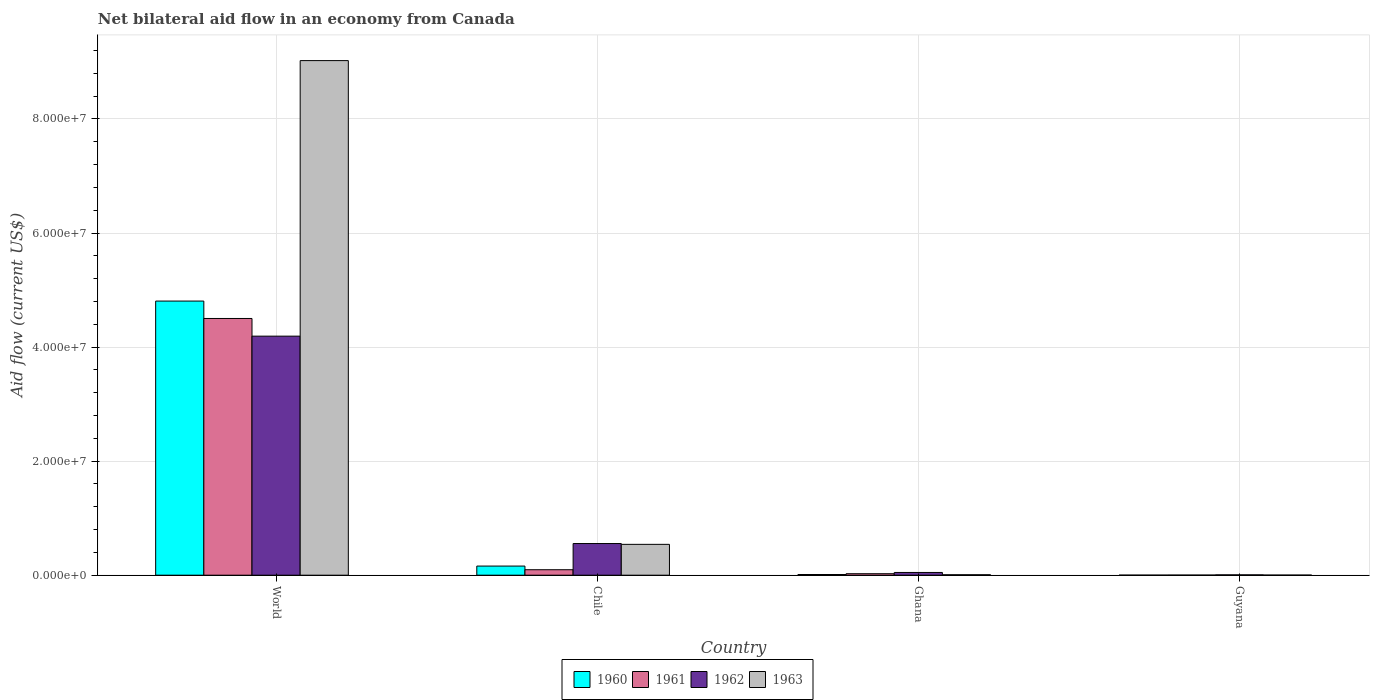Are the number of bars per tick equal to the number of legend labels?
Make the answer very short. Yes. Are the number of bars on each tick of the X-axis equal?
Offer a terse response. Yes. How many bars are there on the 2nd tick from the left?
Provide a short and direct response. 4. How many bars are there on the 4th tick from the right?
Offer a very short reply. 4. What is the label of the 2nd group of bars from the left?
Your answer should be compact. Chile. What is the net bilateral aid flow in 1960 in Chile?
Your response must be concise. 1.60e+06. Across all countries, what is the maximum net bilateral aid flow in 1961?
Keep it short and to the point. 4.50e+07. Across all countries, what is the minimum net bilateral aid flow in 1960?
Give a very brief answer. 10000. In which country was the net bilateral aid flow in 1961 maximum?
Ensure brevity in your answer.  World. In which country was the net bilateral aid flow in 1960 minimum?
Make the answer very short. Guyana. What is the total net bilateral aid flow in 1960 in the graph?
Provide a short and direct response. 4.98e+07. What is the difference between the net bilateral aid flow in 1962 in Guyana and the net bilateral aid flow in 1960 in World?
Provide a short and direct response. -4.80e+07. What is the average net bilateral aid flow in 1962 per country?
Give a very brief answer. 1.20e+07. What is the difference between the net bilateral aid flow of/in 1962 and net bilateral aid flow of/in 1961 in Ghana?
Your response must be concise. 2.20e+05. In how many countries, is the net bilateral aid flow in 1963 greater than 8000000 US$?
Ensure brevity in your answer.  1. What is the ratio of the net bilateral aid flow in 1963 in Chile to that in World?
Provide a succinct answer. 0.06. Is the net bilateral aid flow in 1961 in Chile less than that in Ghana?
Your answer should be very brief. No. What is the difference between the highest and the second highest net bilateral aid flow in 1963?
Ensure brevity in your answer.  9.02e+07. What is the difference between the highest and the lowest net bilateral aid flow in 1962?
Ensure brevity in your answer.  4.19e+07. In how many countries, is the net bilateral aid flow in 1962 greater than the average net bilateral aid flow in 1962 taken over all countries?
Make the answer very short. 1. Is the sum of the net bilateral aid flow in 1960 in Chile and Ghana greater than the maximum net bilateral aid flow in 1962 across all countries?
Give a very brief answer. No. Is it the case that in every country, the sum of the net bilateral aid flow in 1962 and net bilateral aid flow in 1963 is greater than the sum of net bilateral aid flow in 1960 and net bilateral aid flow in 1961?
Keep it short and to the point. No. What is the difference between two consecutive major ticks on the Y-axis?
Provide a succinct answer. 2.00e+07. Does the graph contain any zero values?
Your answer should be very brief. No. How are the legend labels stacked?
Make the answer very short. Horizontal. What is the title of the graph?
Your answer should be very brief. Net bilateral aid flow in an economy from Canada. What is the label or title of the Y-axis?
Keep it short and to the point. Aid flow (current US$). What is the Aid flow (current US$) of 1960 in World?
Offer a very short reply. 4.81e+07. What is the Aid flow (current US$) of 1961 in World?
Provide a short and direct response. 4.50e+07. What is the Aid flow (current US$) in 1962 in World?
Offer a terse response. 4.19e+07. What is the Aid flow (current US$) in 1963 in World?
Make the answer very short. 9.02e+07. What is the Aid flow (current US$) in 1960 in Chile?
Keep it short and to the point. 1.60e+06. What is the Aid flow (current US$) of 1961 in Chile?
Your answer should be very brief. 9.60e+05. What is the Aid flow (current US$) of 1962 in Chile?
Your answer should be very brief. 5.55e+06. What is the Aid flow (current US$) of 1963 in Chile?
Offer a very short reply. 5.41e+06. What is the Aid flow (current US$) of 1960 in Ghana?
Ensure brevity in your answer.  1.20e+05. What is the Aid flow (current US$) in 1961 in Ghana?
Keep it short and to the point. 2.60e+05. What is the Aid flow (current US$) in 1960 in Guyana?
Provide a succinct answer. 10000. What is the Aid flow (current US$) in 1961 in Guyana?
Provide a succinct answer. 2.00e+04. What is the Aid flow (current US$) in 1962 in Guyana?
Offer a terse response. 6.00e+04. What is the Aid flow (current US$) of 1963 in Guyana?
Your response must be concise. 2.00e+04. Across all countries, what is the maximum Aid flow (current US$) of 1960?
Your response must be concise. 4.81e+07. Across all countries, what is the maximum Aid flow (current US$) of 1961?
Provide a short and direct response. 4.50e+07. Across all countries, what is the maximum Aid flow (current US$) in 1962?
Make the answer very short. 4.19e+07. Across all countries, what is the maximum Aid flow (current US$) of 1963?
Provide a succinct answer. 9.02e+07. Across all countries, what is the minimum Aid flow (current US$) in 1960?
Make the answer very short. 10000. Across all countries, what is the minimum Aid flow (current US$) of 1961?
Offer a very short reply. 2.00e+04. Across all countries, what is the minimum Aid flow (current US$) in 1962?
Give a very brief answer. 6.00e+04. What is the total Aid flow (current US$) of 1960 in the graph?
Your answer should be very brief. 4.98e+07. What is the total Aid flow (current US$) in 1961 in the graph?
Your response must be concise. 4.63e+07. What is the total Aid flow (current US$) of 1962 in the graph?
Your response must be concise. 4.80e+07. What is the total Aid flow (current US$) of 1963 in the graph?
Give a very brief answer. 9.58e+07. What is the difference between the Aid flow (current US$) in 1960 in World and that in Chile?
Your answer should be compact. 4.65e+07. What is the difference between the Aid flow (current US$) in 1961 in World and that in Chile?
Your answer should be very brief. 4.41e+07. What is the difference between the Aid flow (current US$) in 1962 in World and that in Chile?
Make the answer very short. 3.64e+07. What is the difference between the Aid flow (current US$) in 1963 in World and that in Chile?
Offer a very short reply. 8.48e+07. What is the difference between the Aid flow (current US$) in 1960 in World and that in Ghana?
Make the answer very short. 4.80e+07. What is the difference between the Aid flow (current US$) of 1961 in World and that in Ghana?
Your answer should be compact. 4.48e+07. What is the difference between the Aid flow (current US$) of 1962 in World and that in Ghana?
Provide a succinct answer. 4.14e+07. What is the difference between the Aid flow (current US$) of 1963 in World and that in Ghana?
Ensure brevity in your answer.  9.02e+07. What is the difference between the Aid flow (current US$) in 1960 in World and that in Guyana?
Make the answer very short. 4.81e+07. What is the difference between the Aid flow (current US$) of 1961 in World and that in Guyana?
Make the answer very short. 4.50e+07. What is the difference between the Aid flow (current US$) in 1962 in World and that in Guyana?
Your answer should be very brief. 4.19e+07. What is the difference between the Aid flow (current US$) in 1963 in World and that in Guyana?
Offer a terse response. 9.02e+07. What is the difference between the Aid flow (current US$) of 1960 in Chile and that in Ghana?
Provide a short and direct response. 1.48e+06. What is the difference between the Aid flow (current US$) of 1962 in Chile and that in Ghana?
Offer a terse response. 5.07e+06. What is the difference between the Aid flow (current US$) of 1963 in Chile and that in Ghana?
Your answer should be very brief. 5.33e+06. What is the difference between the Aid flow (current US$) of 1960 in Chile and that in Guyana?
Offer a very short reply. 1.59e+06. What is the difference between the Aid flow (current US$) in 1961 in Chile and that in Guyana?
Provide a short and direct response. 9.40e+05. What is the difference between the Aid flow (current US$) of 1962 in Chile and that in Guyana?
Your answer should be very brief. 5.49e+06. What is the difference between the Aid flow (current US$) of 1963 in Chile and that in Guyana?
Give a very brief answer. 5.39e+06. What is the difference between the Aid flow (current US$) in 1961 in Ghana and that in Guyana?
Provide a short and direct response. 2.40e+05. What is the difference between the Aid flow (current US$) in 1960 in World and the Aid flow (current US$) in 1961 in Chile?
Provide a succinct answer. 4.71e+07. What is the difference between the Aid flow (current US$) of 1960 in World and the Aid flow (current US$) of 1962 in Chile?
Offer a terse response. 4.25e+07. What is the difference between the Aid flow (current US$) of 1960 in World and the Aid flow (current US$) of 1963 in Chile?
Make the answer very short. 4.27e+07. What is the difference between the Aid flow (current US$) of 1961 in World and the Aid flow (current US$) of 1962 in Chile?
Ensure brevity in your answer.  3.95e+07. What is the difference between the Aid flow (current US$) of 1961 in World and the Aid flow (current US$) of 1963 in Chile?
Your answer should be very brief. 3.96e+07. What is the difference between the Aid flow (current US$) of 1962 in World and the Aid flow (current US$) of 1963 in Chile?
Offer a terse response. 3.65e+07. What is the difference between the Aid flow (current US$) in 1960 in World and the Aid flow (current US$) in 1961 in Ghana?
Give a very brief answer. 4.78e+07. What is the difference between the Aid flow (current US$) in 1960 in World and the Aid flow (current US$) in 1962 in Ghana?
Keep it short and to the point. 4.76e+07. What is the difference between the Aid flow (current US$) of 1960 in World and the Aid flow (current US$) of 1963 in Ghana?
Give a very brief answer. 4.80e+07. What is the difference between the Aid flow (current US$) in 1961 in World and the Aid flow (current US$) in 1962 in Ghana?
Make the answer very short. 4.45e+07. What is the difference between the Aid flow (current US$) in 1961 in World and the Aid flow (current US$) in 1963 in Ghana?
Provide a short and direct response. 4.49e+07. What is the difference between the Aid flow (current US$) in 1962 in World and the Aid flow (current US$) in 1963 in Ghana?
Give a very brief answer. 4.18e+07. What is the difference between the Aid flow (current US$) in 1960 in World and the Aid flow (current US$) in 1961 in Guyana?
Offer a terse response. 4.80e+07. What is the difference between the Aid flow (current US$) of 1960 in World and the Aid flow (current US$) of 1962 in Guyana?
Provide a succinct answer. 4.80e+07. What is the difference between the Aid flow (current US$) in 1960 in World and the Aid flow (current US$) in 1963 in Guyana?
Your answer should be very brief. 4.80e+07. What is the difference between the Aid flow (current US$) of 1961 in World and the Aid flow (current US$) of 1962 in Guyana?
Offer a very short reply. 4.50e+07. What is the difference between the Aid flow (current US$) of 1961 in World and the Aid flow (current US$) of 1963 in Guyana?
Give a very brief answer. 4.50e+07. What is the difference between the Aid flow (current US$) in 1962 in World and the Aid flow (current US$) in 1963 in Guyana?
Provide a short and direct response. 4.19e+07. What is the difference between the Aid flow (current US$) of 1960 in Chile and the Aid flow (current US$) of 1961 in Ghana?
Give a very brief answer. 1.34e+06. What is the difference between the Aid flow (current US$) of 1960 in Chile and the Aid flow (current US$) of 1962 in Ghana?
Keep it short and to the point. 1.12e+06. What is the difference between the Aid flow (current US$) of 1960 in Chile and the Aid flow (current US$) of 1963 in Ghana?
Your answer should be compact. 1.52e+06. What is the difference between the Aid flow (current US$) of 1961 in Chile and the Aid flow (current US$) of 1962 in Ghana?
Make the answer very short. 4.80e+05. What is the difference between the Aid flow (current US$) in 1961 in Chile and the Aid flow (current US$) in 1963 in Ghana?
Offer a terse response. 8.80e+05. What is the difference between the Aid flow (current US$) of 1962 in Chile and the Aid flow (current US$) of 1963 in Ghana?
Provide a succinct answer. 5.47e+06. What is the difference between the Aid flow (current US$) of 1960 in Chile and the Aid flow (current US$) of 1961 in Guyana?
Your answer should be compact. 1.58e+06. What is the difference between the Aid flow (current US$) in 1960 in Chile and the Aid flow (current US$) in 1962 in Guyana?
Your response must be concise. 1.54e+06. What is the difference between the Aid flow (current US$) in 1960 in Chile and the Aid flow (current US$) in 1963 in Guyana?
Make the answer very short. 1.58e+06. What is the difference between the Aid flow (current US$) in 1961 in Chile and the Aid flow (current US$) in 1963 in Guyana?
Provide a short and direct response. 9.40e+05. What is the difference between the Aid flow (current US$) of 1962 in Chile and the Aid flow (current US$) of 1963 in Guyana?
Give a very brief answer. 5.53e+06. What is the difference between the Aid flow (current US$) in 1961 in Ghana and the Aid flow (current US$) in 1962 in Guyana?
Give a very brief answer. 2.00e+05. What is the difference between the Aid flow (current US$) in 1961 in Ghana and the Aid flow (current US$) in 1963 in Guyana?
Make the answer very short. 2.40e+05. What is the difference between the Aid flow (current US$) in 1962 in Ghana and the Aid flow (current US$) in 1963 in Guyana?
Provide a short and direct response. 4.60e+05. What is the average Aid flow (current US$) of 1960 per country?
Your answer should be very brief. 1.24e+07. What is the average Aid flow (current US$) of 1961 per country?
Your response must be concise. 1.16e+07. What is the average Aid flow (current US$) of 1962 per country?
Your answer should be very brief. 1.20e+07. What is the average Aid flow (current US$) in 1963 per country?
Your response must be concise. 2.39e+07. What is the difference between the Aid flow (current US$) of 1960 and Aid flow (current US$) of 1961 in World?
Provide a succinct answer. 3.05e+06. What is the difference between the Aid flow (current US$) of 1960 and Aid flow (current US$) of 1962 in World?
Your response must be concise. 6.15e+06. What is the difference between the Aid flow (current US$) in 1960 and Aid flow (current US$) in 1963 in World?
Keep it short and to the point. -4.22e+07. What is the difference between the Aid flow (current US$) of 1961 and Aid flow (current US$) of 1962 in World?
Your response must be concise. 3.10e+06. What is the difference between the Aid flow (current US$) of 1961 and Aid flow (current US$) of 1963 in World?
Ensure brevity in your answer.  -4.52e+07. What is the difference between the Aid flow (current US$) in 1962 and Aid flow (current US$) in 1963 in World?
Your response must be concise. -4.83e+07. What is the difference between the Aid flow (current US$) in 1960 and Aid flow (current US$) in 1961 in Chile?
Ensure brevity in your answer.  6.40e+05. What is the difference between the Aid flow (current US$) of 1960 and Aid flow (current US$) of 1962 in Chile?
Your answer should be very brief. -3.95e+06. What is the difference between the Aid flow (current US$) of 1960 and Aid flow (current US$) of 1963 in Chile?
Keep it short and to the point. -3.81e+06. What is the difference between the Aid flow (current US$) in 1961 and Aid flow (current US$) in 1962 in Chile?
Make the answer very short. -4.59e+06. What is the difference between the Aid flow (current US$) in 1961 and Aid flow (current US$) in 1963 in Chile?
Provide a succinct answer. -4.45e+06. What is the difference between the Aid flow (current US$) of 1962 and Aid flow (current US$) of 1963 in Chile?
Offer a very short reply. 1.40e+05. What is the difference between the Aid flow (current US$) in 1960 and Aid flow (current US$) in 1962 in Ghana?
Ensure brevity in your answer.  -3.60e+05. What is the difference between the Aid flow (current US$) of 1961 and Aid flow (current US$) of 1963 in Ghana?
Provide a succinct answer. 1.80e+05. What is the difference between the Aid flow (current US$) in 1960 and Aid flow (current US$) in 1963 in Guyana?
Provide a succinct answer. -10000. What is the difference between the Aid flow (current US$) of 1961 and Aid flow (current US$) of 1962 in Guyana?
Provide a succinct answer. -4.00e+04. What is the difference between the Aid flow (current US$) of 1961 and Aid flow (current US$) of 1963 in Guyana?
Keep it short and to the point. 0. What is the ratio of the Aid flow (current US$) of 1960 in World to that in Chile?
Give a very brief answer. 30.04. What is the ratio of the Aid flow (current US$) in 1961 in World to that in Chile?
Your answer should be compact. 46.9. What is the ratio of the Aid flow (current US$) in 1962 in World to that in Chile?
Ensure brevity in your answer.  7.55. What is the ratio of the Aid flow (current US$) of 1963 in World to that in Chile?
Make the answer very short. 16.68. What is the ratio of the Aid flow (current US$) of 1960 in World to that in Ghana?
Provide a succinct answer. 400.58. What is the ratio of the Aid flow (current US$) in 1961 in World to that in Ghana?
Make the answer very short. 173.15. What is the ratio of the Aid flow (current US$) of 1962 in World to that in Ghana?
Your answer should be very brief. 87.33. What is the ratio of the Aid flow (current US$) in 1963 in World to that in Ghana?
Your answer should be compact. 1128. What is the ratio of the Aid flow (current US$) in 1960 in World to that in Guyana?
Your response must be concise. 4807. What is the ratio of the Aid flow (current US$) of 1961 in World to that in Guyana?
Your answer should be very brief. 2251. What is the ratio of the Aid flow (current US$) of 1962 in World to that in Guyana?
Your answer should be compact. 698.67. What is the ratio of the Aid flow (current US$) in 1963 in World to that in Guyana?
Provide a short and direct response. 4512. What is the ratio of the Aid flow (current US$) in 1960 in Chile to that in Ghana?
Make the answer very short. 13.33. What is the ratio of the Aid flow (current US$) in 1961 in Chile to that in Ghana?
Ensure brevity in your answer.  3.69. What is the ratio of the Aid flow (current US$) in 1962 in Chile to that in Ghana?
Ensure brevity in your answer.  11.56. What is the ratio of the Aid flow (current US$) in 1963 in Chile to that in Ghana?
Give a very brief answer. 67.62. What is the ratio of the Aid flow (current US$) in 1960 in Chile to that in Guyana?
Ensure brevity in your answer.  160. What is the ratio of the Aid flow (current US$) in 1961 in Chile to that in Guyana?
Your answer should be compact. 48. What is the ratio of the Aid flow (current US$) of 1962 in Chile to that in Guyana?
Offer a very short reply. 92.5. What is the ratio of the Aid flow (current US$) of 1963 in Chile to that in Guyana?
Give a very brief answer. 270.5. What is the ratio of the Aid flow (current US$) of 1960 in Ghana to that in Guyana?
Offer a terse response. 12. What is the ratio of the Aid flow (current US$) in 1963 in Ghana to that in Guyana?
Keep it short and to the point. 4. What is the difference between the highest and the second highest Aid flow (current US$) in 1960?
Your answer should be compact. 4.65e+07. What is the difference between the highest and the second highest Aid flow (current US$) in 1961?
Provide a short and direct response. 4.41e+07. What is the difference between the highest and the second highest Aid flow (current US$) in 1962?
Provide a succinct answer. 3.64e+07. What is the difference between the highest and the second highest Aid flow (current US$) of 1963?
Ensure brevity in your answer.  8.48e+07. What is the difference between the highest and the lowest Aid flow (current US$) in 1960?
Give a very brief answer. 4.81e+07. What is the difference between the highest and the lowest Aid flow (current US$) in 1961?
Provide a succinct answer. 4.50e+07. What is the difference between the highest and the lowest Aid flow (current US$) in 1962?
Your answer should be compact. 4.19e+07. What is the difference between the highest and the lowest Aid flow (current US$) of 1963?
Offer a very short reply. 9.02e+07. 